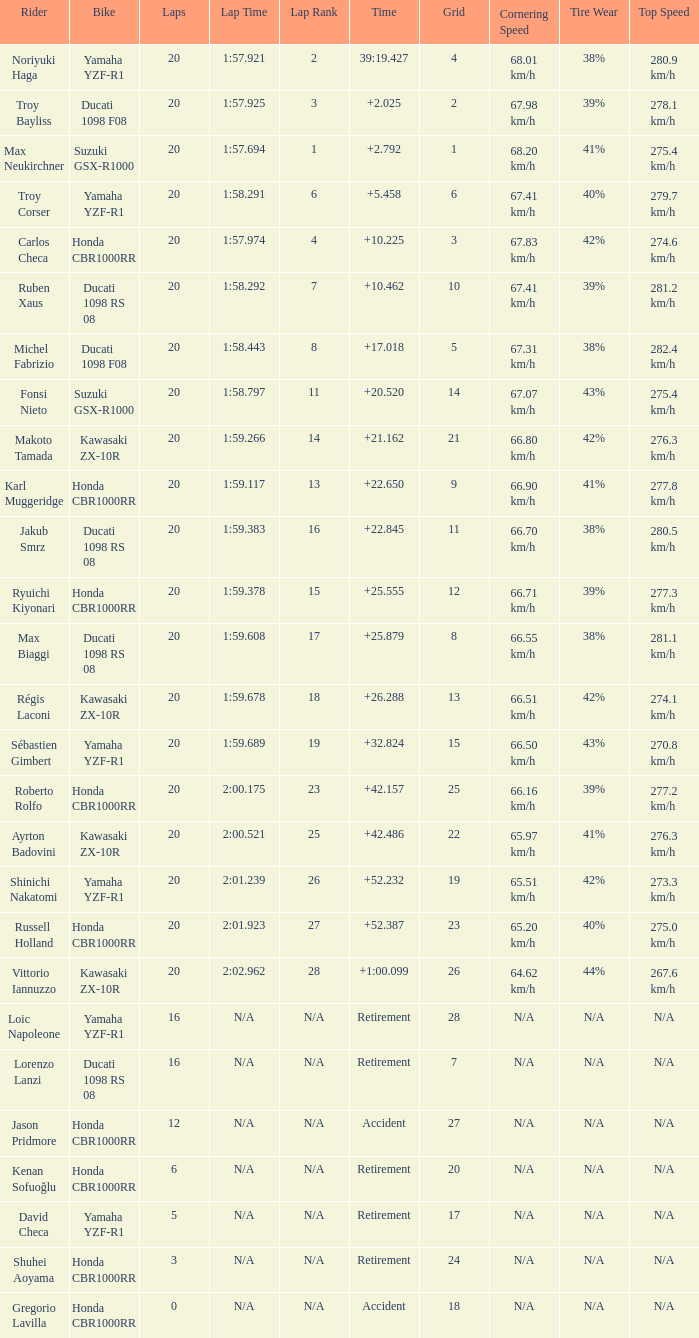What is the time of Max Biaggi with more than 2 grids, 20 laps? 25.879. 